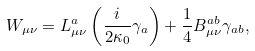Convert formula to latex. <formula><loc_0><loc_0><loc_500><loc_500>W _ { \mu \nu } = L _ { \mu \nu } ^ { a } \left ( \frac { i } { 2 \kappa _ { 0 } } \gamma _ { a } \right ) + \frac { 1 } { 4 } B _ { \mu \nu } ^ { a b } \gamma _ { a b } ,</formula> 